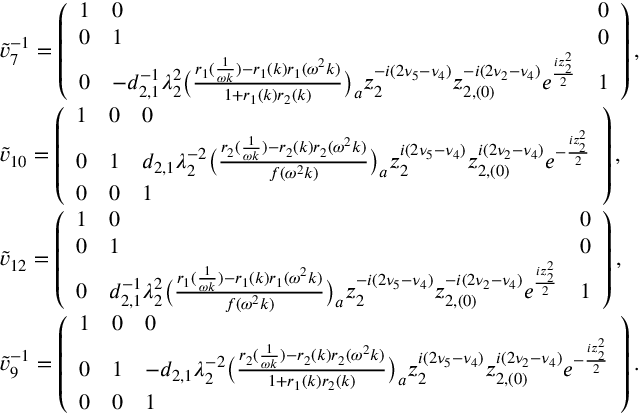Convert formula to latex. <formula><loc_0><loc_0><loc_500><loc_500>\begin{array} { r l } & { \tilde { v } _ { 7 } ^ { - 1 } = \left ( \begin{array} { l l l } { 1 } & { 0 } & { 0 } \\ { 0 } & { 1 } & { 0 } \\ { 0 } & { - d _ { 2 , 1 } ^ { - 1 } \lambda _ { 2 } ^ { 2 } \left ( \frac { r _ { 1 } ( \frac { 1 } { \omega k } ) - r _ { 1 } ( k ) r _ { 1 } ( \omega ^ { 2 } k ) } { 1 + r _ { 1 } ( k ) r _ { 2 } ( k ) } \right ) _ { a } z _ { 2 } ^ { - i ( 2 \nu _ { 5 } - \nu _ { 4 } ) } z _ { 2 , ( 0 ) } ^ { - i ( 2 \nu _ { 2 } - \nu _ { 4 } ) } e ^ { \frac { i z _ { 2 } ^ { 2 } } { 2 } } } & { 1 } \end{array} \right ) , } \\ & { \tilde { v } _ { 1 0 } = \left ( \begin{array} { l l l } { 1 } & { 0 } & { 0 } \\ { 0 } & { 1 } & { d _ { 2 , 1 } \lambda _ { 2 } ^ { - 2 } \left ( \frac { r _ { 2 } ( \frac { 1 } { \omega k } ) - r _ { 2 } ( k ) r _ { 2 } ( \omega ^ { 2 } k ) } { f ( \omega ^ { 2 } k ) } \right ) _ { a } z _ { 2 } ^ { i ( 2 \nu _ { 5 } - \nu _ { 4 } ) } z _ { 2 , ( 0 ) } ^ { i ( 2 \nu _ { 2 } - \nu _ { 4 } ) } e ^ { - \frac { i z _ { 2 } ^ { 2 } } { 2 } } } \\ { 0 } & { 0 } & { 1 } \end{array} \right ) , } \\ & { \tilde { v } _ { 1 2 } = \left ( \begin{array} { l l l } { 1 } & { 0 } & { 0 } \\ { 0 } & { 1 } & { 0 } \\ { 0 } & { d _ { 2 , 1 } ^ { - 1 } \lambda _ { 2 } ^ { 2 } \left ( \frac { r _ { 1 } ( \frac { 1 } { \omega k } ) - r _ { 1 } ( k ) r _ { 1 } ( \omega ^ { 2 } k ) } { f ( \omega ^ { 2 } k ) } \right ) _ { a } z _ { 2 } ^ { - i ( 2 \nu _ { 5 } - \nu _ { 4 } ) } z _ { 2 , ( 0 ) } ^ { - i ( 2 \nu _ { 2 } - \nu _ { 4 } ) } e ^ { \frac { i z _ { 2 } ^ { 2 } } { 2 } } } & { 1 } \end{array} \right ) , } \\ & { \tilde { v } _ { 9 } ^ { - 1 } = \left ( \begin{array} { l l l } { 1 } & { 0 } & { 0 } \\ { 0 } & { 1 } & { - d _ { 2 , 1 } \lambda _ { 2 } ^ { - 2 } \left ( \frac { r _ { 2 } ( \frac { 1 } { \omega k } ) - r _ { 2 } ( k ) r _ { 2 } ( \omega ^ { 2 } k ) } { 1 + r _ { 1 } ( k ) r _ { 2 } ( k ) } \right ) _ { a } z _ { 2 } ^ { i ( 2 \nu _ { 5 } - \nu _ { 4 } ) } z _ { 2 , ( 0 ) } ^ { i ( 2 \nu _ { 2 } - \nu _ { 4 } ) } e ^ { - \frac { i z _ { 2 } ^ { 2 } } { 2 } } } \\ { 0 } & { 0 } & { 1 } \end{array} \right ) . } \end{array}</formula> 